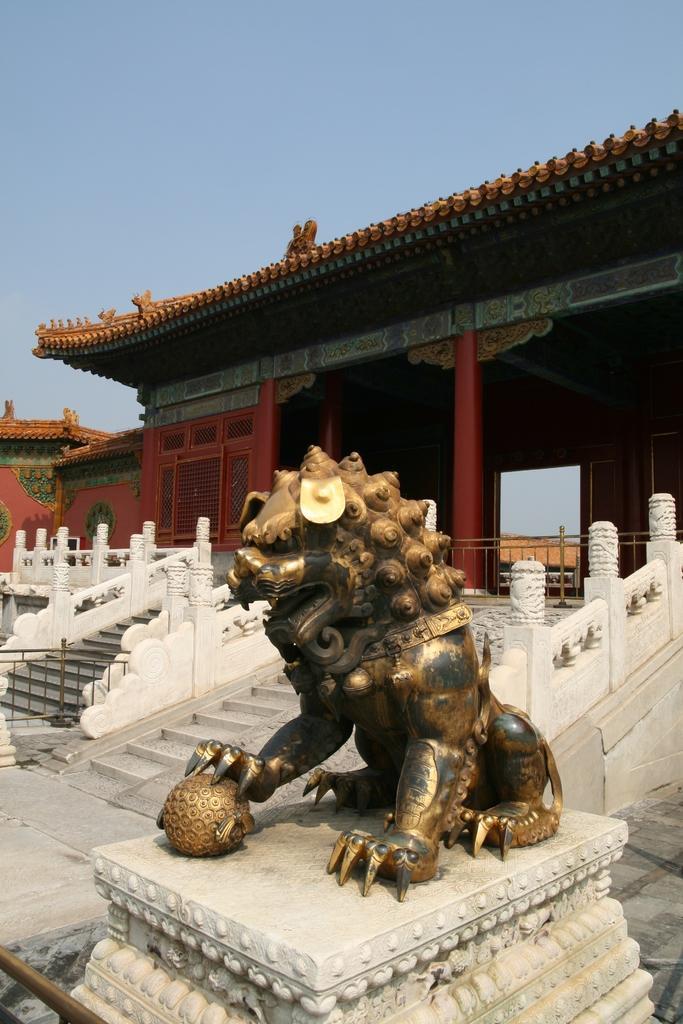In one or two sentences, can you explain what this image depicts? In this picture I can see a sculpture of a lion, there are stairs, iron grilles, there is a building, and in the background there is the sky. 